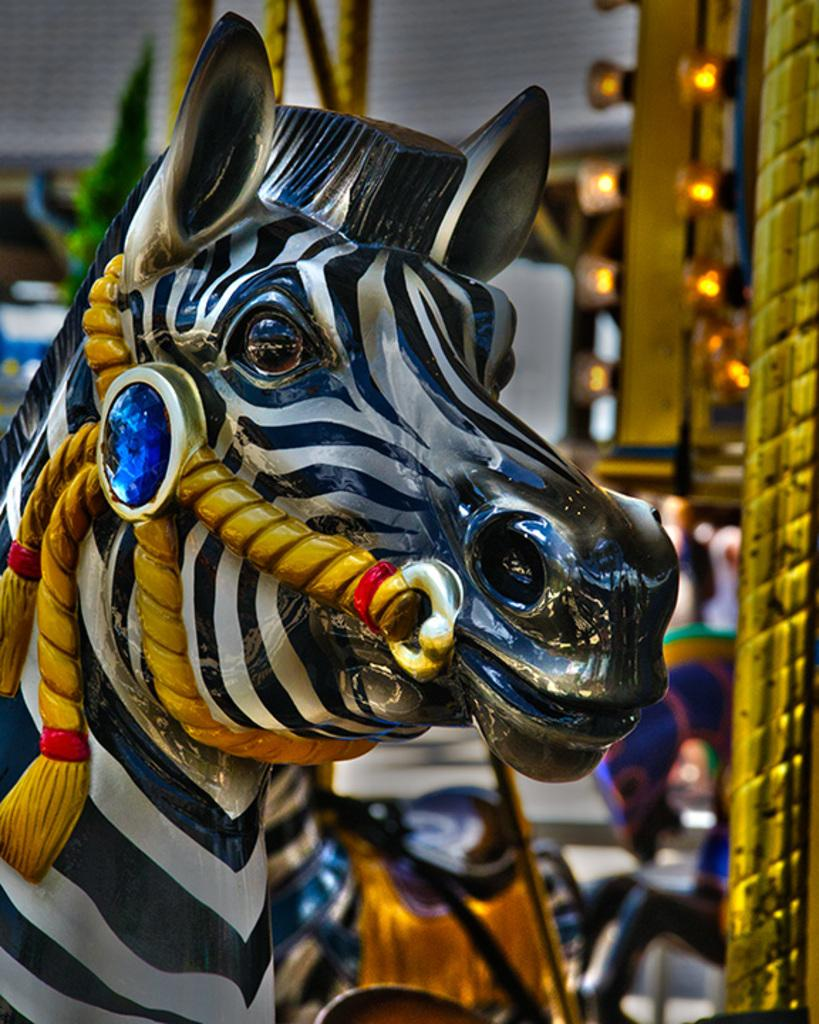What is the main subject in the foreground of the image? There is a toy in the foreground of the image. What can be seen in the background of the image? There are lights visible in the background of the image. Are there any other objects present in the background of the image? Yes, there are other objects present in the background of the image. How many horses can be seen wearing mittens in the image? There are no horses or mittens present in the image. What type of cattle is visible in the image? There is no cattle present in the image. 